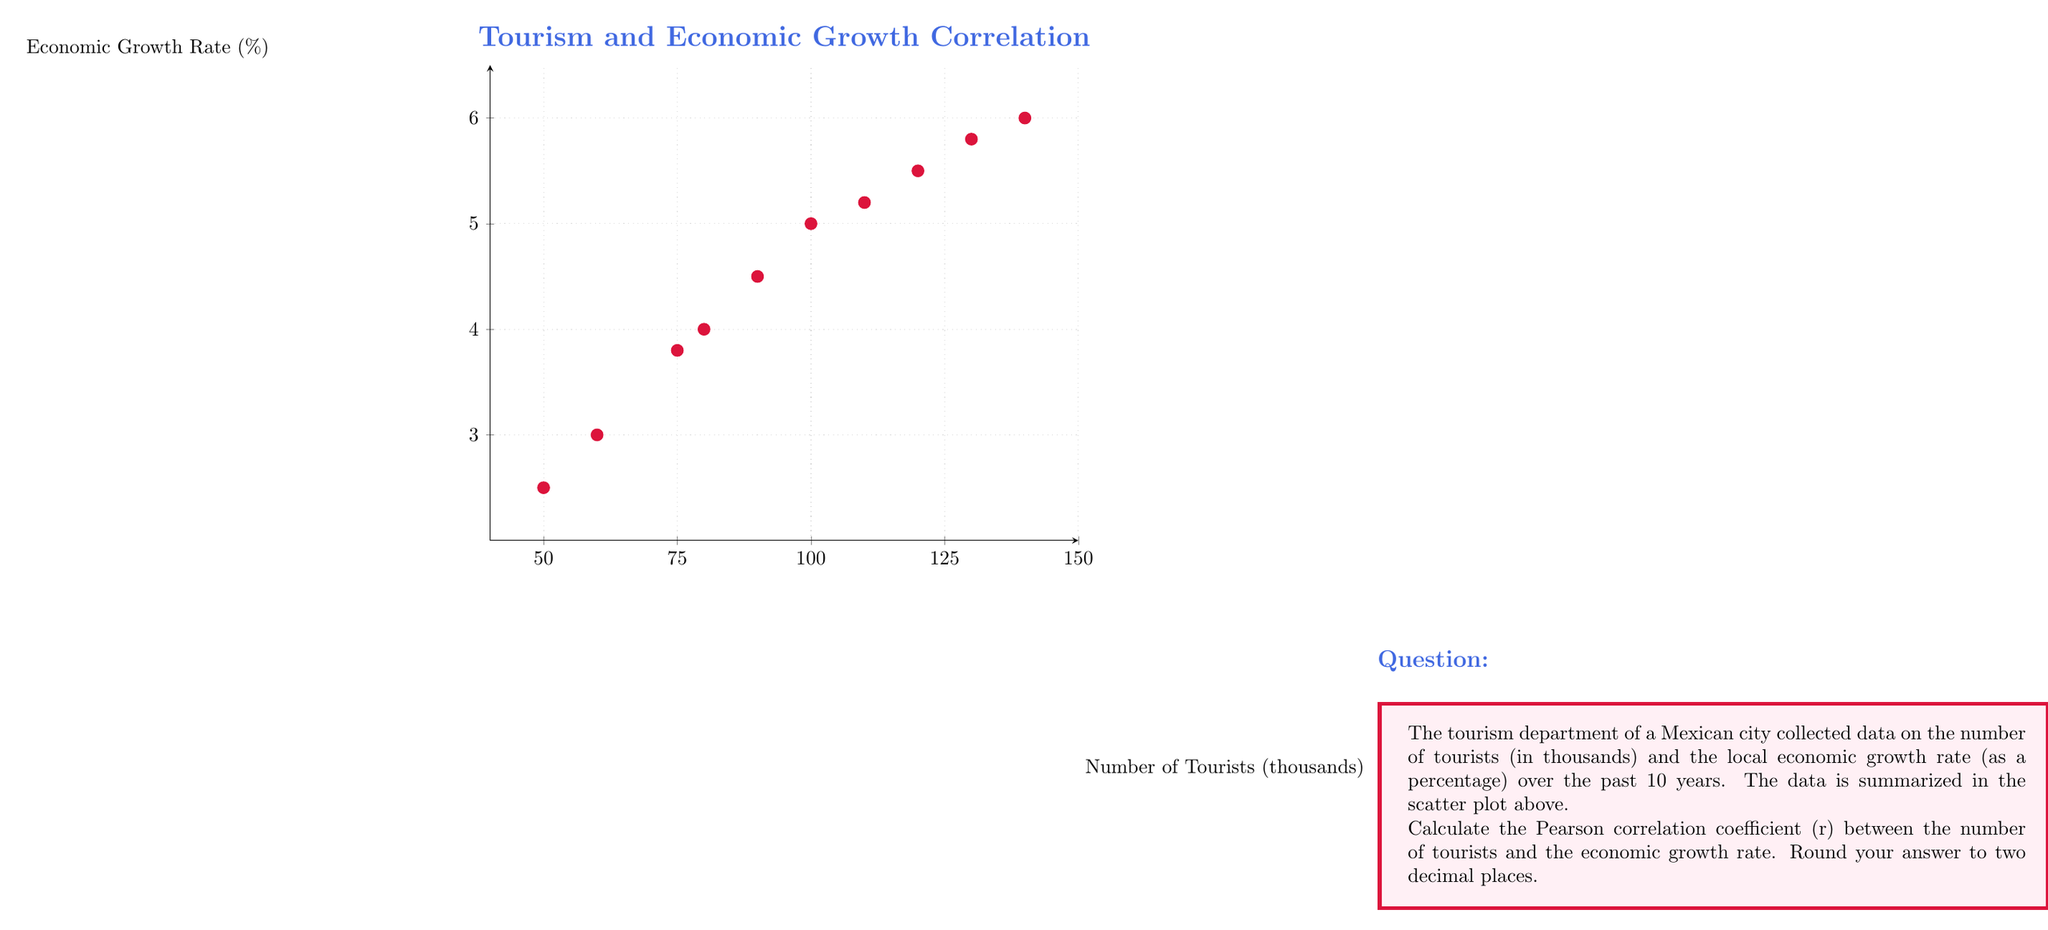Show me your answer to this math problem. To calculate the Pearson correlation coefficient (r), we'll use the formula:

$$ r = \frac{\sum_{i=1}^{n} (x_i - \bar{x})(y_i - \bar{y})}{\sqrt{\sum_{i=1}^{n} (x_i - \bar{x})^2 \sum_{i=1}^{n} (y_i - \bar{y})^2}} $$

Where:
$x_i$ = number of tourists (in thousands)
$y_i$ = economic growth rate (%)
$\bar{x}$ = mean of x values
$\bar{y}$ = mean of y values
n = number of data points (10)

Step 1: Calculate means
$\bar{x} = \frac{50+60+75+80+90+100+110+120+130+140}{10} = 95.5$
$\bar{y} = \frac{2.5+3.0+3.8+4.0+4.5+5.0+5.2+5.5+5.8+6.0}{10} = 4.53$

Step 2: Calculate $(x_i - \bar{x})$, $(y_i - \bar{y})$, $(x_i - \bar{x})^2$, $(y_i - \bar{y})^2$, and $(x_i - \bar{x})(y_i - \bar{y})$ for each data point.

Step 3: Sum up the values calculated in Step 2:
$\sum (x_i - \bar{x})(y_i - \bar{y}) = 1128.25$
$\sum (x_i - \bar{x})^2 = 16712.25$
$\sum (y_i - \bar{y})^2 = 16.2075$

Step 4: Apply the formula:

$$ r = \frac{1128.25}{\sqrt{16712.25 \times 16.2075}} = \frac{1128.25}{520.7656} = 0.9953 $$

Step 5: Round to two decimal places: 0.99
Answer: 0.99 